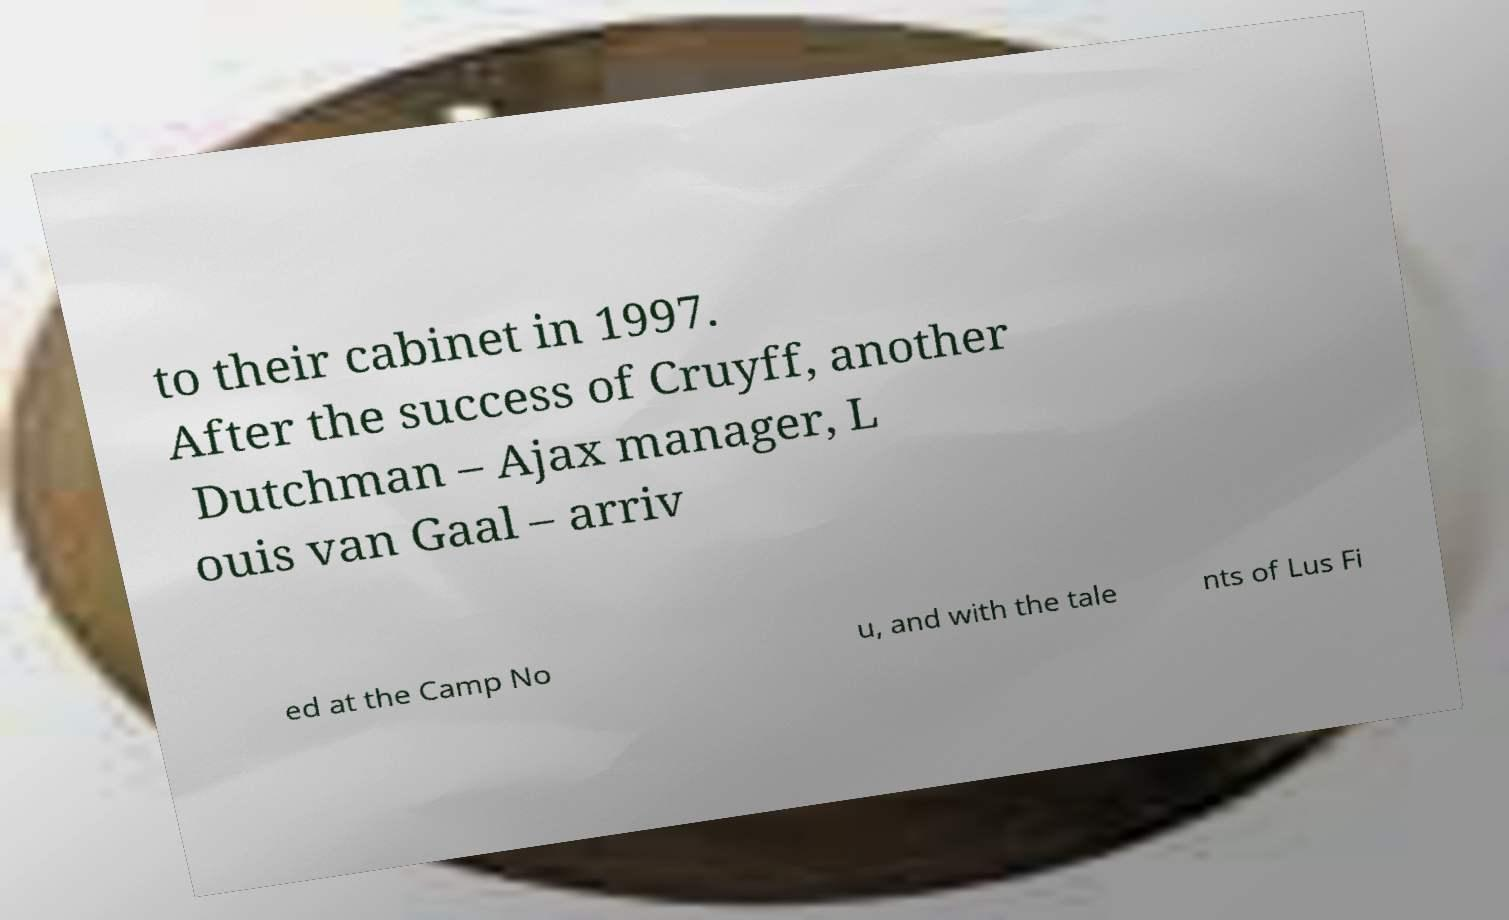I need the written content from this picture converted into text. Can you do that? to their cabinet in 1997. After the success of Cruyff, another Dutchman – Ajax manager, L ouis van Gaal – arriv ed at the Camp No u, and with the tale nts of Lus Fi 